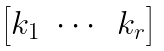Convert formula to latex. <formula><loc_0><loc_0><loc_500><loc_500>\begin{bmatrix} k _ { 1 } & \cdots & k _ { r } \end{bmatrix}</formula> 